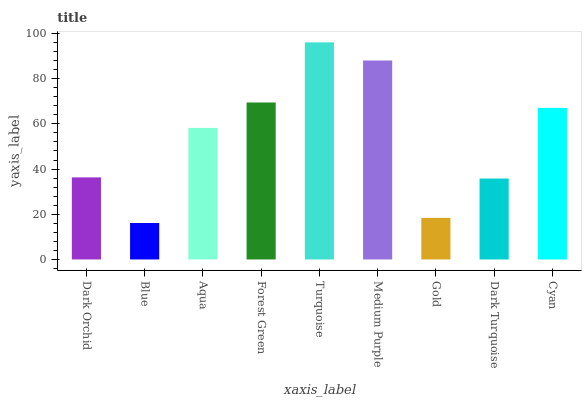Is Blue the minimum?
Answer yes or no. Yes. Is Turquoise the maximum?
Answer yes or no. Yes. Is Aqua the minimum?
Answer yes or no. No. Is Aqua the maximum?
Answer yes or no. No. Is Aqua greater than Blue?
Answer yes or no. Yes. Is Blue less than Aqua?
Answer yes or no. Yes. Is Blue greater than Aqua?
Answer yes or no. No. Is Aqua less than Blue?
Answer yes or no. No. Is Aqua the high median?
Answer yes or no. Yes. Is Aqua the low median?
Answer yes or no. Yes. Is Blue the high median?
Answer yes or no. No. Is Cyan the low median?
Answer yes or no. No. 